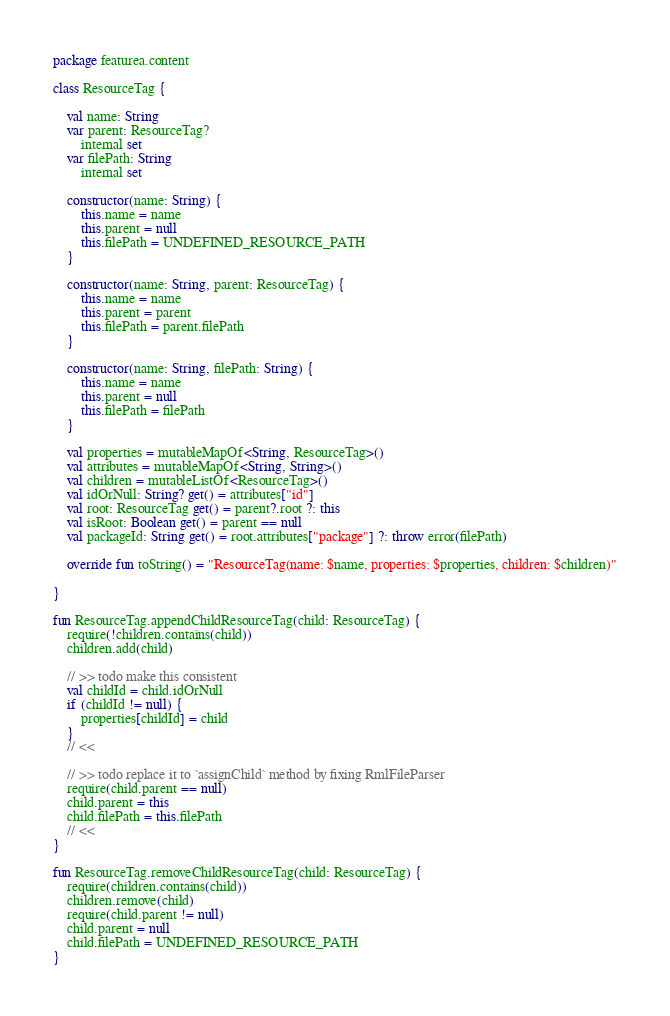<code> <loc_0><loc_0><loc_500><loc_500><_Kotlin_>package featurea.content

class ResourceTag {

    val name: String
    var parent: ResourceTag?
        internal set
    var filePath: String
        internal set

    constructor(name: String) {
        this.name = name
        this.parent = null
        this.filePath = UNDEFINED_RESOURCE_PATH
    }

    constructor(name: String, parent: ResourceTag) {
        this.name = name
        this.parent = parent
        this.filePath = parent.filePath
    }

    constructor(name: String, filePath: String) {
        this.name = name
        this.parent = null
        this.filePath = filePath
    }

    val properties = mutableMapOf<String, ResourceTag>()
    val attributes = mutableMapOf<String, String>()
    val children = mutableListOf<ResourceTag>()
    val idOrNull: String? get() = attributes["id"]
    val root: ResourceTag get() = parent?.root ?: this
    val isRoot: Boolean get() = parent == null
    val packageId: String get() = root.attributes["package"] ?: throw error(filePath)

    override fun toString() = "ResourceTag(name: $name, properties: $properties, children: $children)"

}

fun ResourceTag.appendChildResourceTag(child: ResourceTag) {
    require(!children.contains(child))
    children.add(child)

    // >> todo make this consistent
    val childId = child.idOrNull
    if (childId != null) {
        properties[childId] = child
    }
    // <<

    // >> todo replace it to `assignChild` method by fixing RmlFileParser
    require(child.parent == null)
    child.parent = this
    child.filePath = this.filePath
    // <<
}

fun ResourceTag.removeChildResourceTag(child: ResourceTag) {
    require(children.contains(child))
    children.remove(child)
    require(child.parent != null)
    child.parent = null
    child.filePath = UNDEFINED_RESOURCE_PATH
}
</code> 